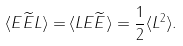<formula> <loc_0><loc_0><loc_500><loc_500>\langle E \widetilde { E } L \rangle = & \, \langle L E \widetilde { E } \rangle = \frac { 1 } { 2 } \langle L ^ { 2 } \rangle .</formula> 